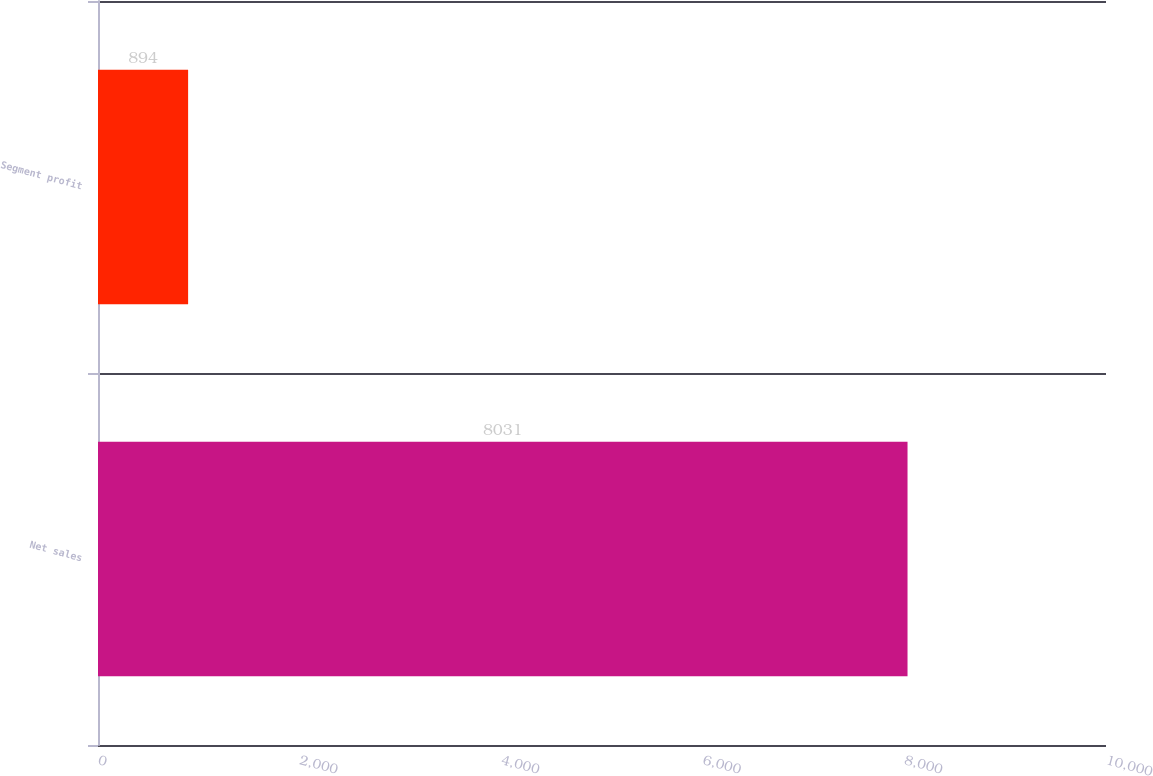Convert chart to OTSL. <chart><loc_0><loc_0><loc_500><loc_500><bar_chart><fcel>Net sales<fcel>Segment profit<nl><fcel>8031<fcel>894<nl></chart> 